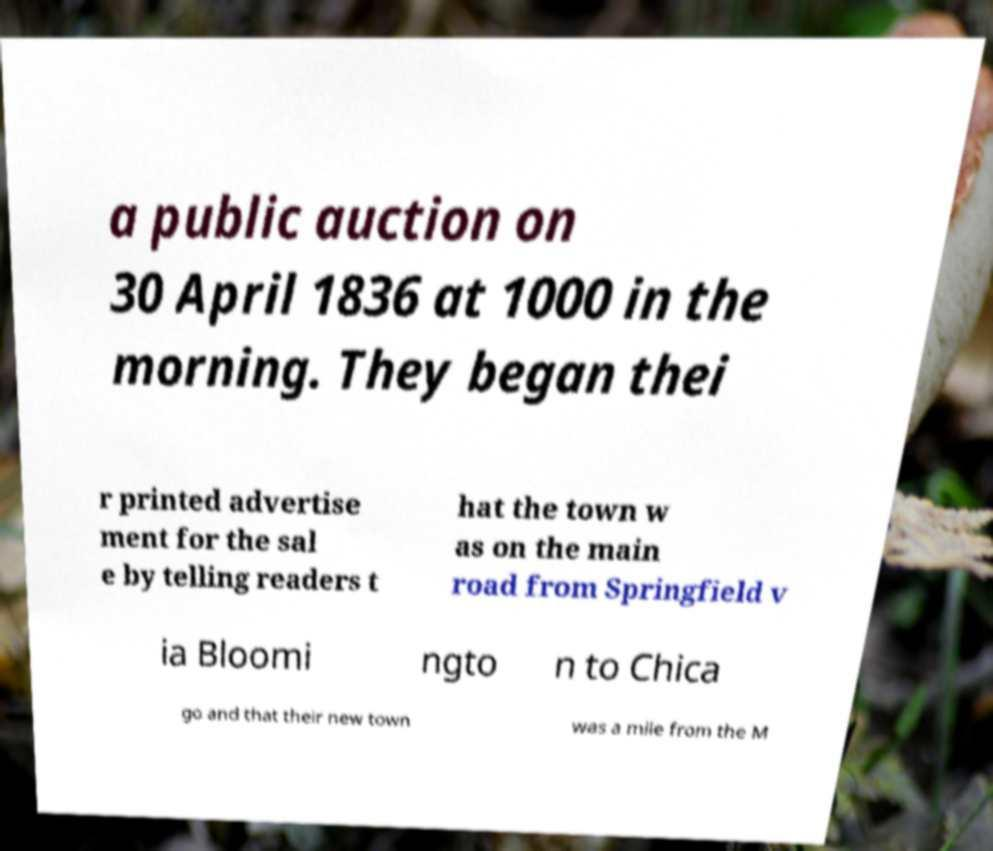I need the written content from this picture converted into text. Can you do that? a public auction on 30 April 1836 at 1000 in the morning. They began thei r printed advertise ment for the sal e by telling readers t hat the town w as on the main road from Springfield v ia Bloomi ngto n to Chica go and that their new town was a mile from the M 